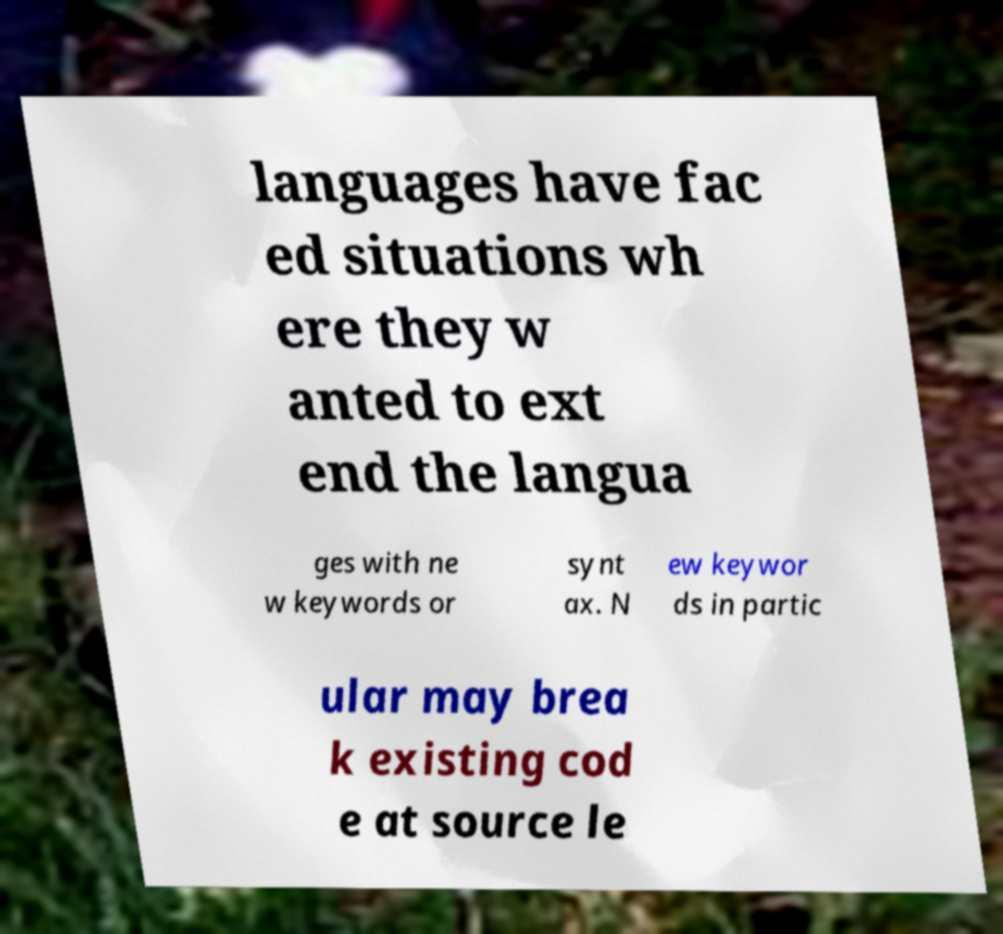For documentation purposes, I need the text within this image transcribed. Could you provide that? languages have fac ed situations wh ere they w anted to ext end the langua ges with ne w keywords or synt ax. N ew keywor ds in partic ular may brea k existing cod e at source le 